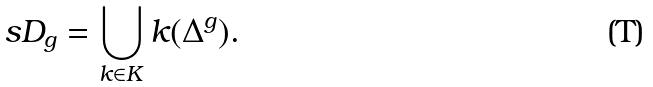Convert formula to latex. <formula><loc_0><loc_0><loc_500><loc_500>\ s D _ { g } = \bigcup _ { k \in K } k ( \Delta ^ { g } ) .</formula> 